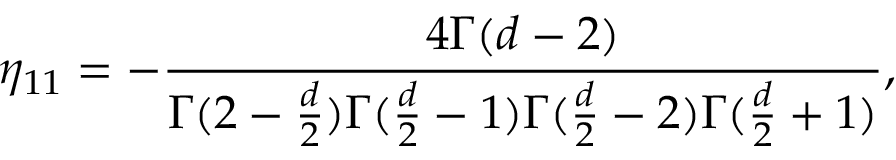<formula> <loc_0><loc_0><loc_500><loc_500>\eta _ { 1 1 } = - { \frac { 4 \Gamma ( d - 2 ) } { \Gamma ( 2 - { \frac { d } { 2 } } ) \Gamma ( { \frac { d } { 2 } } - 1 ) \Gamma ( { \frac { d } { 2 } } - 2 ) \Gamma ( { \frac { d } { 2 } } + 1 ) } } ,</formula> 